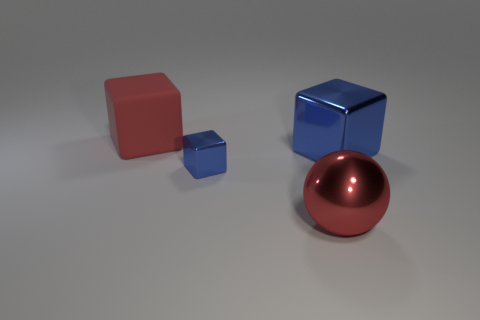What is the material of the big ball that is the same color as the rubber object?
Provide a succinct answer. Metal. What color is the thing that is to the right of the large red metal thing?
Your answer should be compact. Blue. There is a red object on the right side of the red cube; is its size the same as the tiny object?
Provide a short and direct response. No. There is a metal sphere that is the same color as the large rubber cube; what is its size?
Your response must be concise. Large. Are there any other red cubes that have the same size as the red rubber cube?
Ensure brevity in your answer.  No. Does the big metallic object that is on the right side of the large red metallic object have the same color as the metallic cube on the left side of the metal ball?
Offer a very short reply. Yes. Are there any big balls that have the same color as the tiny metal block?
Your answer should be very brief. No. How many other things are there of the same shape as the big red matte thing?
Your answer should be compact. 2. There is a blue metallic object in front of the big blue block; what shape is it?
Make the answer very short. Cube. There is a tiny blue metal object; is its shape the same as the large metal object that is behind the tiny blue metallic object?
Your response must be concise. Yes. 